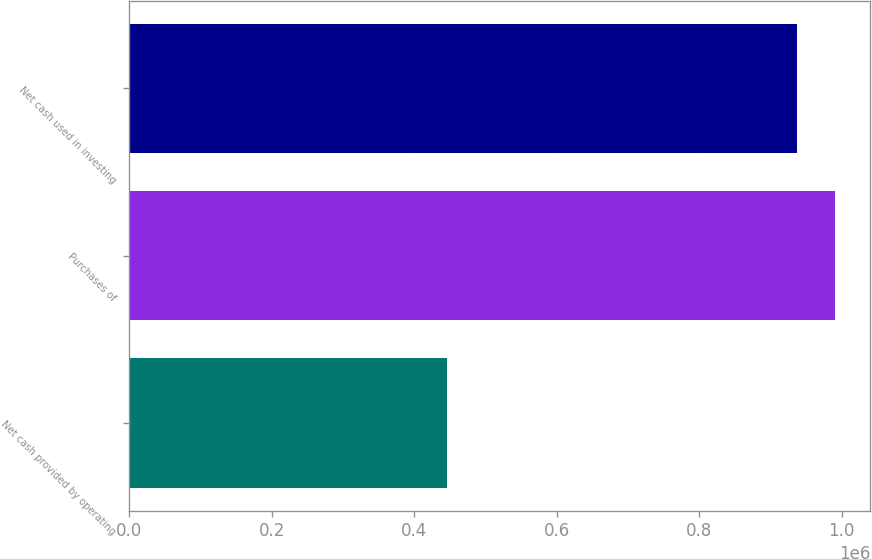Convert chart to OTSL. <chart><loc_0><loc_0><loc_500><loc_500><bar_chart><fcel>Net cash provided by operating<fcel>Purchases of<fcel>Net cash used in investing<nl><fcel>446179<fcel>990717<fcel>936756<nl></chart> 